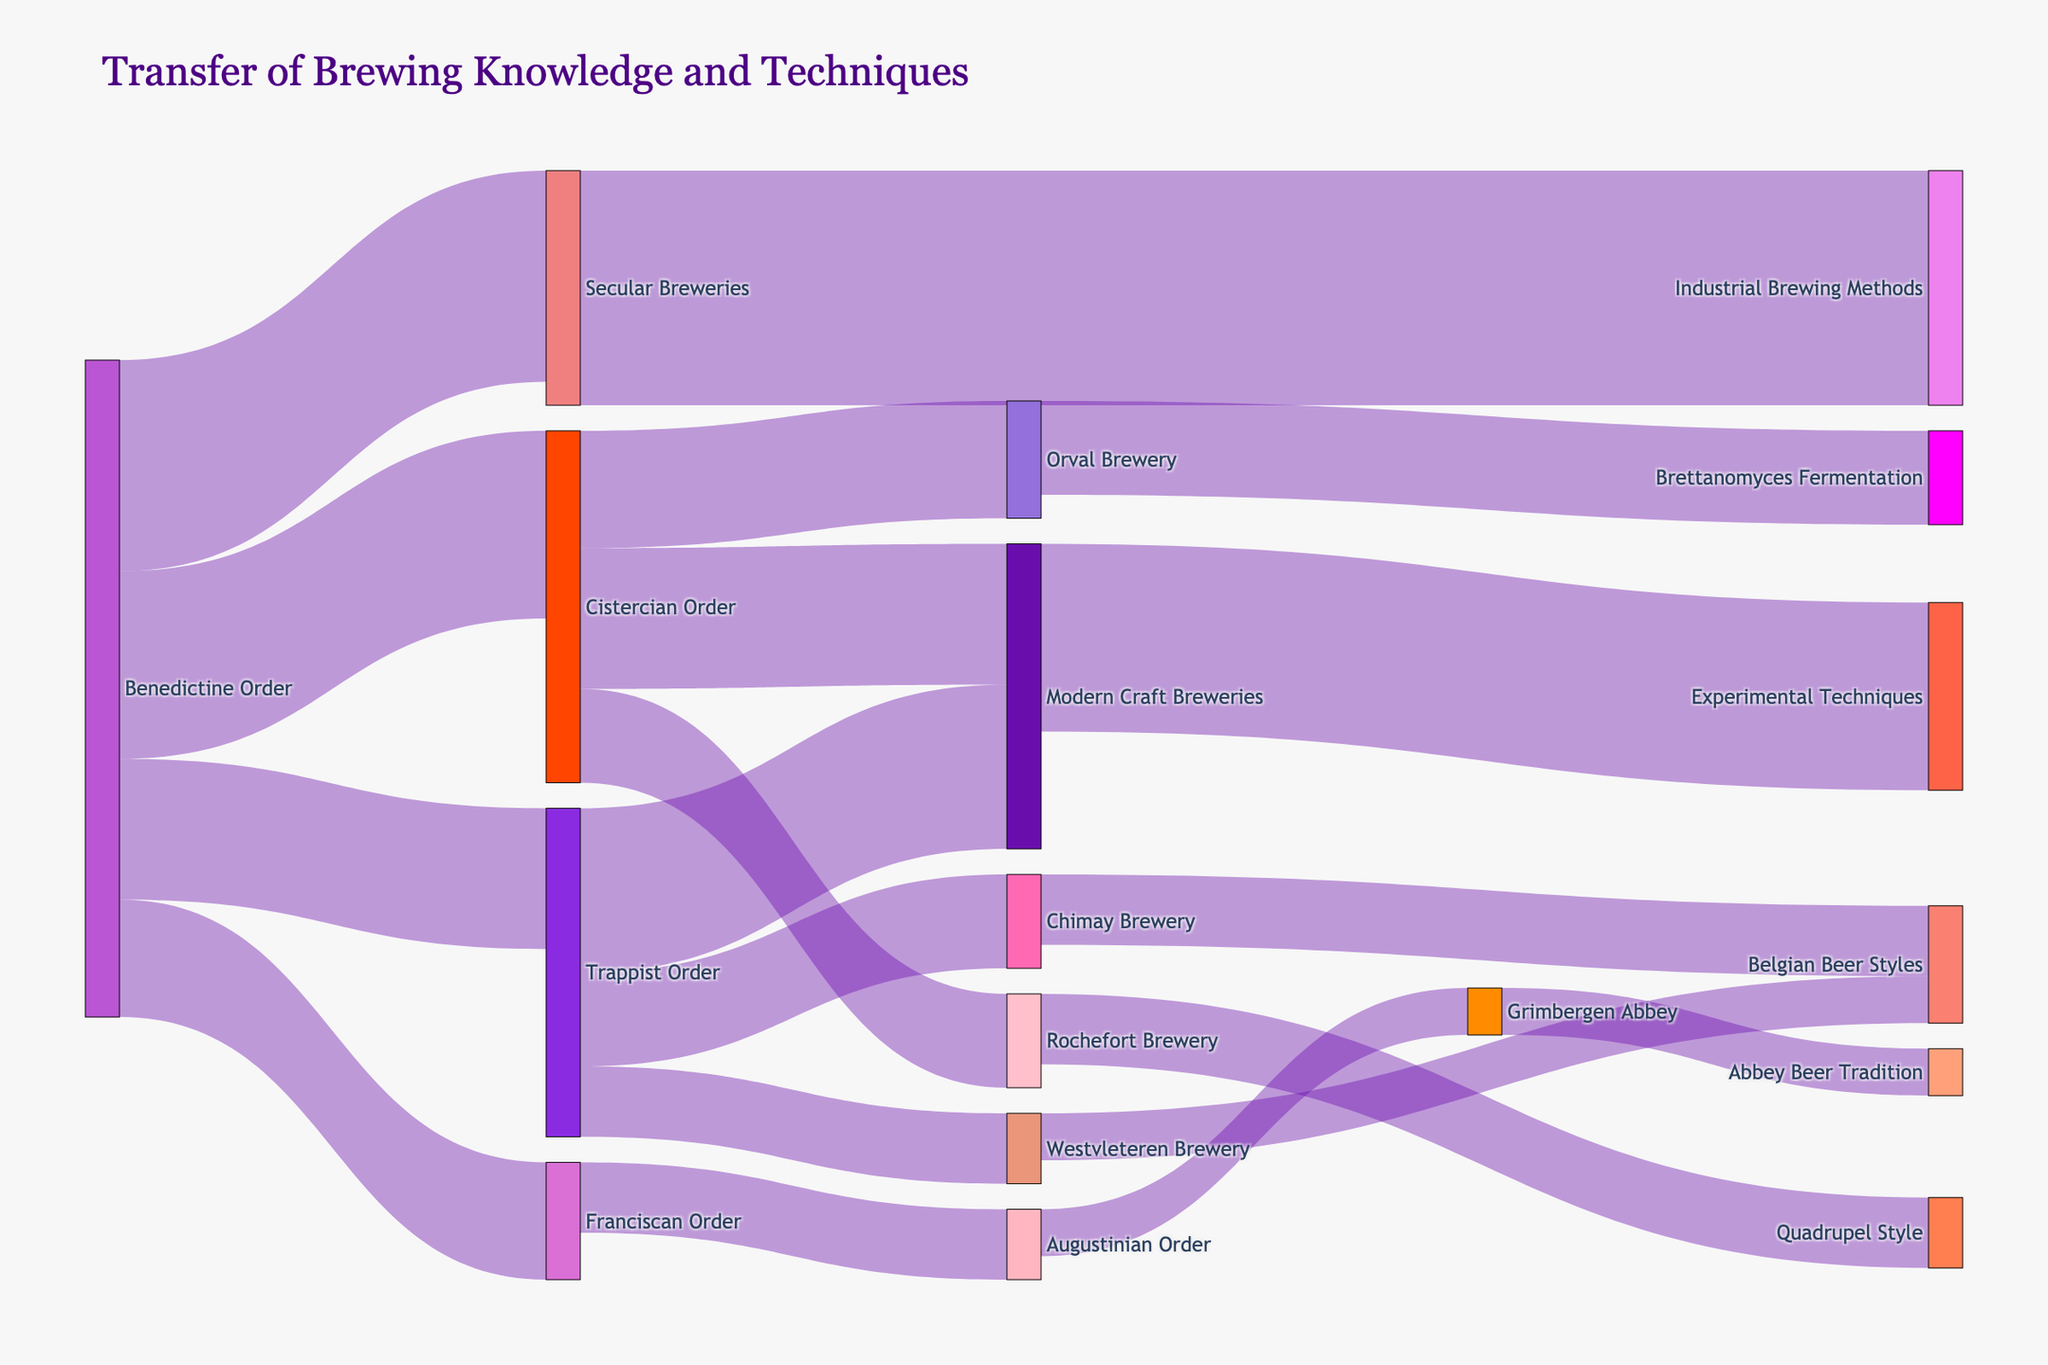What is the title of the Sankey Diagram? The title is written at the top of the figure. It states the main topic of the diagram.
Answer: Transfer of Brewing Knowledge and Techniques Which monastic order has the highest number of transfers listed? Check the number of times each monastic order appears as a source and count them. The order with the highest count has the most transfers.
Answer: Benedictine Order How many transfers are directed towards 'Modern Craft Breweries'? Look for all links targeting 'Modern Craft Breweries' and sum their values.
Answer: 65 Between the Benedictine Order and Cistercian Order, which has a higher value of total transfers to other orders and breweries? Sum all transfer values for both 'Benedictine Order' and 'Cistercian Order' as sources and compare the totals.
Answer: Benedictine Order What is the total value of transfers from the 'Trappist Order' to both 'Chimay Brewery' and 'Westvleteren Brewery'? Identify the values of transfers from 'Trappist Order' to 'Chimay Brewery' and 'Westvleteren Brewery' and add them.
Answer: 35 What brewing technique is associated with transfers from Orval Brewery? Identify the specific brewing technique mentioned in the target linked to the 'Orval Brewery'.
Answer: Brettanomyces Fermentation Which monastic order has transfers directed towards the 'Quadrupel Style'? Find the origin order of the transfer link that ends at 'Quadrupel Style'.
Answer: Rochefort Brewery How do the transfer values to 'Industrial Brewing Methods' compare with those to 'Experimental Techniques'? Compare the values of transfers directed towards 'Industrial Brewing Methods' and 'Experimental Techniques'.
Answer: Industrial Brewing Methods has a higher value What is the combined value of all transfers from 'Secular Breweries'? Identify all transfers originating from 'Secular Breweries', sum their values to find the total.
Answer: 50 How many different breweries are involved in receiving knowledge and techniques from monastic orders? Count the unique brewery names that appear as targets in the dataset.
Answer: 6 